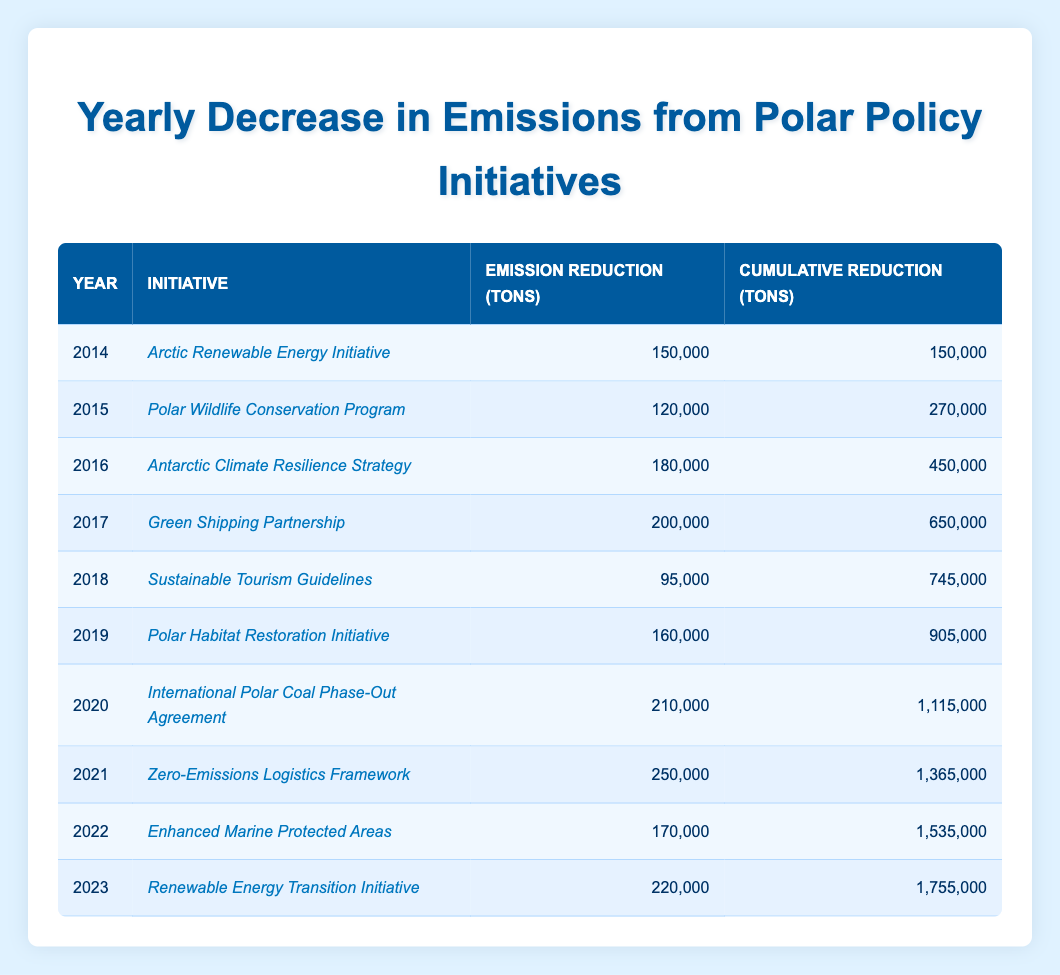What was the emission reduction in tons in the year 2016? In the table, locating the row for the year 2016 shows that the emission reduction was 180,000 tons.
Answer: 180,000 Which initiative had the highest emission reduction from 2014 to 2023? Scanning through the table, the "Zero-Emissions Logistics Framework" initiated in 2021 shows the highest reduction of 250,000 tons.
Answer: Zero-Emissions Logistics Framework What is the cumulative reduction in emissions by the end of 2020? To determine this, look at the cumulative reduction column for the year 2020, which states the cumulative reduction is 1,115,000 tons.
Answer: 1,115,000 What was the difference in emissions reduction between 2017 and 2018? The emission reduction for 2017 was 200,000 tons, and for 2018, it was 95,000 tons. The difference is 200,000 - 95,000 = 105,000 tons.
Answer: 105,000 Is the cumulative reduction in emissions for 2023 greater than for 2021? Checking the cumulative reduction values, for 2023 it is 1,755,000 tons and for 2021 it is 1,365,000 tons. Since 1,755,000 is greater than 1,365,000, the statement is true.
Answer: Yes What was the total emission reduction from the first three initiatives combined? For the first three years, the initiatives had emission reductions of 150,000 tons (2014) + 120,000 tons (2015) + 180,000 tons (2016). Adding these gives a total of 150,000 + 120,000 + 180,000 = 450,000 tons.
Answer: 450,000 How much did emissions decrease in 2019 compared to 2016? The emission reductions for 2019 and 2016 are 160,000 tons and 180,000 tons, respectively. The decrease is 180,000 - 160,000 = 20,000 tons.
Answer: 20,000 Which year saw a decrease in the emission reduction compared to the previous year? Looking through the data, 2018 saw a decrease from 200,000 tons in 2017 to 95,000 tons in 2018. Thus, 2018 had a decrease.
Answer: 2018 What was the total cumulative reduction at the end of 2022? The cumulative reduction listed for the year 2022 in the table is 1,535,000 tons, which gives the total cumulative reduction at that point.
Answer: 1,535,000 